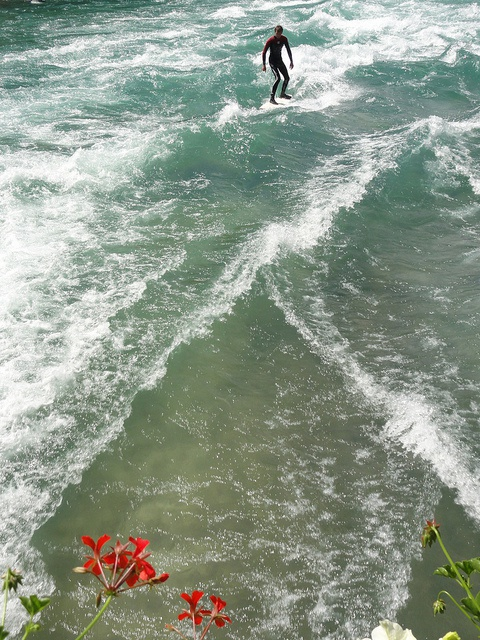Describe the objects in this image and their specific colors. I can see people in black, gray, darkgray, and lightgray tones and surfboard in black, white, darkgray, and gray tones in this image. 